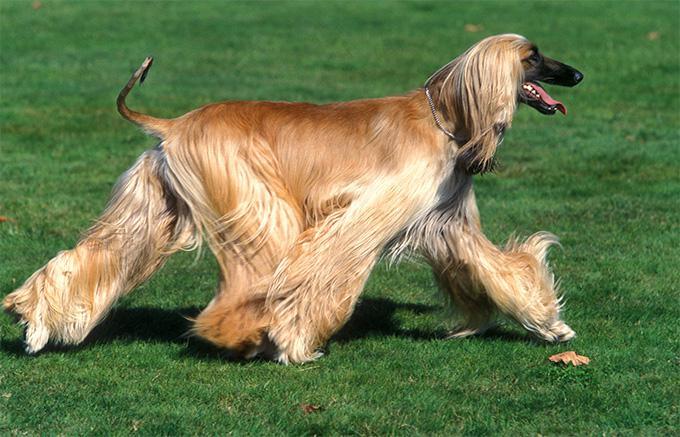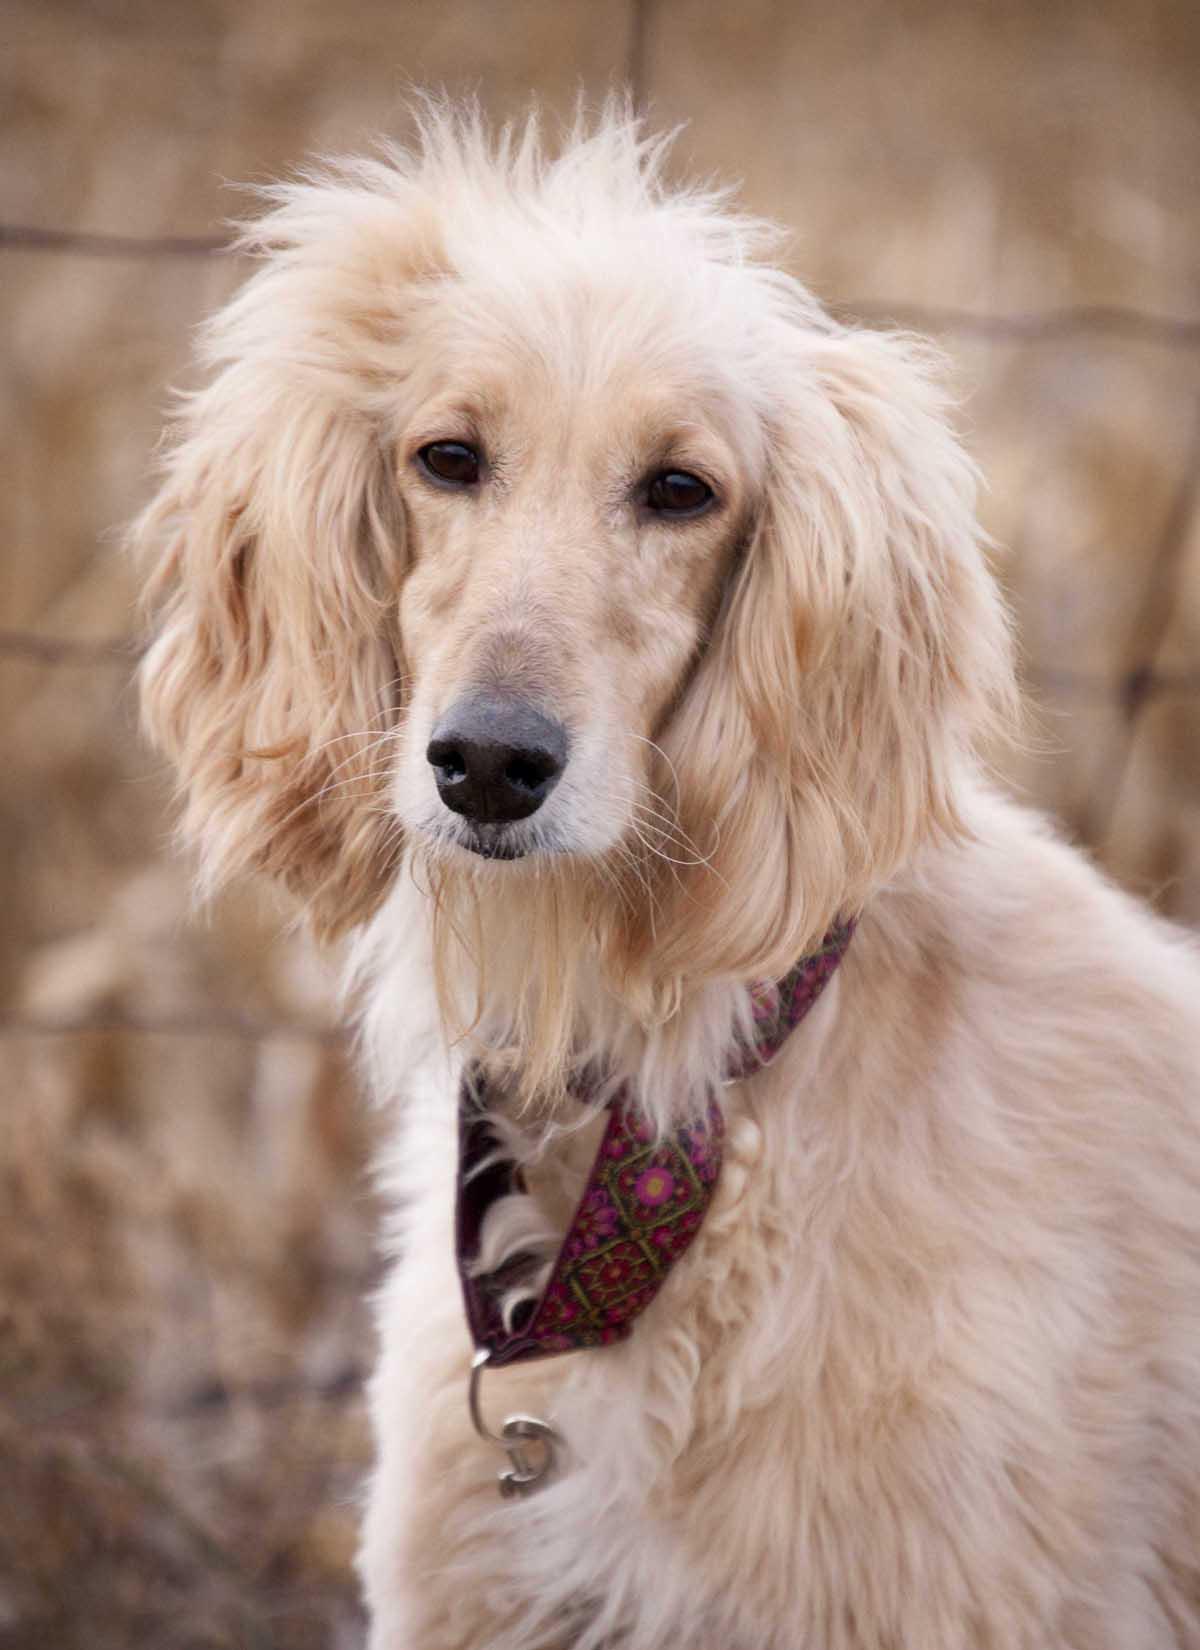The first image is the image on the left, the second image is the image on the right. Considering the images on both sides, is "At least one image shows a hound on all fours on the grassy ground." valid? Answer yes or no. Yes. 